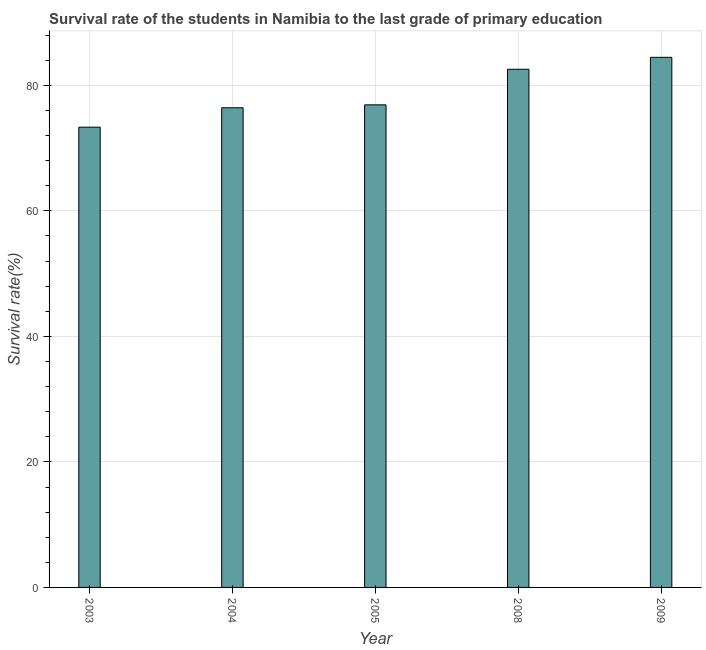Does the graph contain grids?
Offer a very short reply. Yes. What is the title of the graph?
Provide a short and direct response. Survival rate of the students in Namibia to the last grade of primary education. What is the label or title of the X-axis?
Give a very brief answer. Year. What is the label or title of the Y-axis?
Make the answer very short. Survival rate(%). What is the survival rate in primary education in 2008?
Offer a terse response. 82.56. Across all years, what is the maximum survival rate in primary education?
Offer a terse response. 84.46. Across all years, what is the minimum survival rate in primary education?
Provide a succinct answer. 73.33. What is the sum of the survival rate in primary education?
Keep it short and to the point. 393.68. What is the difference between the survival rate in primary education in 2003 and 2009?
Offer a terse response. -11.13. What is the average survival rate in primary education per year?
Your answer should be compact. 78.74. What is the median survival rate in primary education?
Your answer should be compact. 76.89. Do a majority of the years between 2003 and 2004 (inclusive) have survival rate in primary education greater than 56 %?
Make the answer very short. Yes. What is the ratio of the survival rate in primary education in 2004 to that in 2008?
Your response must be concise. 0.93. Is the survival rate in primary education in 2003 less than that in 2005?
Keep it short and to the point. Yes. Is the difference between the survival rate in primary education in 2003 and 2004 greater than the difference between any two years?
Keep it short and to the point. No. What is the difference between the highest and the lowest survival rate in primary education?
Keep it short and to the point. 11.13. How many bars are there?
Offer a very short reply. 5. How many years are there in the graph?
Your answer should be very brief. 5. Are the values on the major ticks of Y-axis written in scientific E-notation?
Provide a succinct answer. No. What is the Survival rate(%) of 2003?
Your response must be concise. 73.33. What is the Survival rate(%) in 2004?
Your answer should be compact. 76.43. What is the Survival rate(%) of 2005?
Make the answer very short. 76.89. What is the Survival rate(%) of 2008?
Your answer should be compact. 82.56. What is the Survival rate(%) of 2009?
Provide a succinct answer. 84.46. What is the difference between the Survival rate(%) in 2003 and 2004?
Make the answer very short. -3.1. What is the difference between the Survival rate(%) in 2003 and 2005?
Provide a succinct answer. -3.56. What is the difference between the Survival rate(%) in 2003 and 2008?
Offer a terse response. -9.23. What is the difference between the Survival rate(%) in 2003 and 2009?
Provide a short and direct response. -11.13. What is the difference between the Survival rate(%) in 2004 and 2005?
Provide a short and direct response. -0.47. What is the difference between the Survival rate(%) in 2004 and 2008?
Offer a very short reply. -6.13. What is the difference between the Survival rate(%) in 2004 and 2009?
Keep it short and to the point. -8.03. What is the difference between the Survival rate(%) in 2005 and 2008?
Offer a terse response. -5.67. What is the difference between the Survival rate(%) in 2005 and 2009?
Provide a succinct answer. -7.57. What is the difference between the Survival rate(%) in 2008 and 2009?
Give a very brief answer. -1.9. What is the ratio of the Survival rate(%) in 2003 to that in 2004?
Offer a terse response. 0.96. What is the ratio of the Survival rate(%) in 2003 to that in 2005?
Your answer should be very brief. 0.95. What is the ratio of the Survival rate(%) in 2003 to that in 2008?
Ensure brevity in your answer.  0.89. What is the ratio of the Survival rate(%) in 2003 to that in 2009?
Keep it short and to the point. 0.87. What is the ratio of the Survival rate(%) in 2004 to that in 2008?
Ensure brevity in your answer.  0.93. What is the ratio of the Survival rate(%) in 2004 to that in 2009?
Your response must be concise. 0.91. What is the ratio of the Survival rate(%) in 2005 to that in 2008?
Ensure brevity in your answer.  0.93. What is the ratio of the Survival rate(%) in 2005 to that in 2009?
Keep it short and to the point. 0.91. What is the ratio of the Survival rate(%) in 2008 to that in 2009?
Keep it short and to the point. 0.98. 